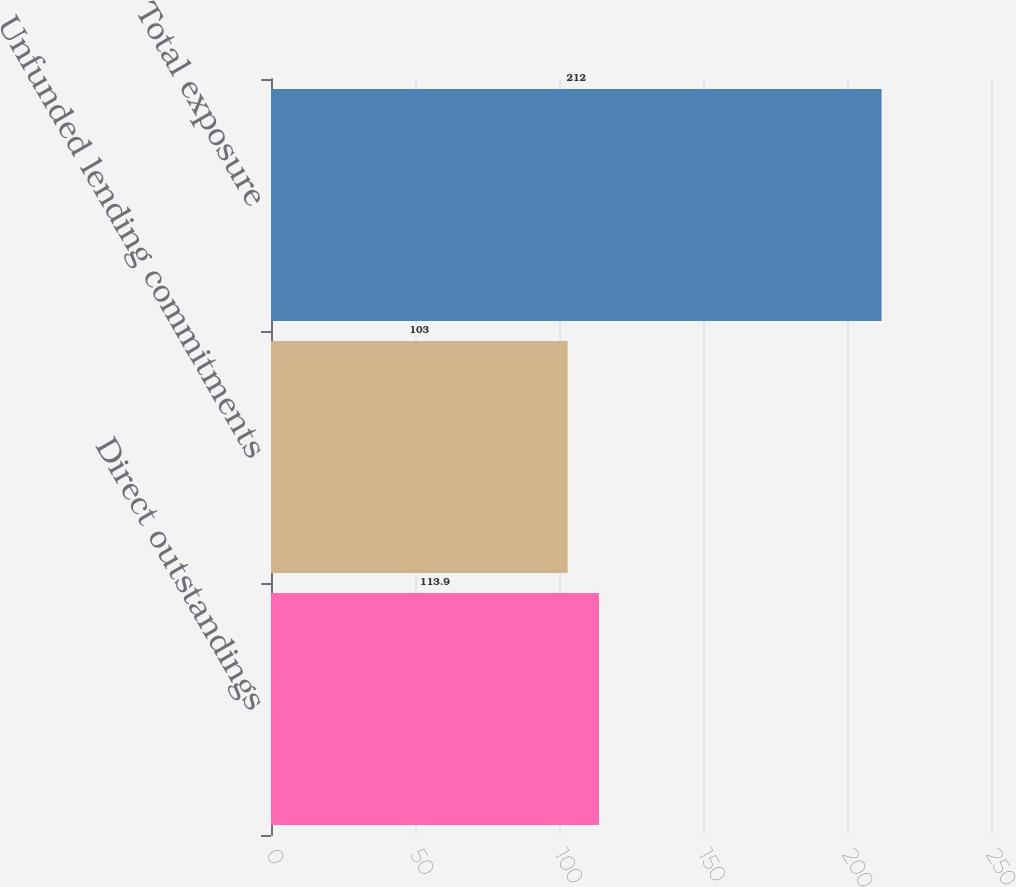Convert chart to OTSL. <chart><loc_0><loc_0><loc_500><loc_500><bar_chart><fcel>Direct outstandings<fcel>Unfunded lending commitments<fcel>Total exposure<nl><fcel>113.9<fcel>103<fcel>212<nl></chart> 